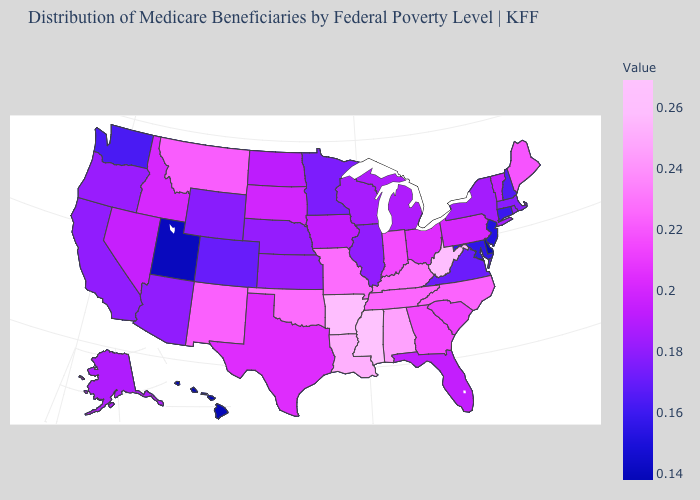Which states hav the highest value in the MidWest?
Keep it brief. Missouri. Among the states that border Massachusetts , does New York have the highest value?
Be succinct. No. Which states have the lowest value in the USA?
Be succinct. Delaware, Hawaii. Which states have the highest value in the USA?
Quick response, please. Mississippi. Among the states that border Pennsylvania , which have the highest value?
Be succinct. West Virginia. Among the states that border Idaho , which have the lowest value?
Answer briefly. Utah. 